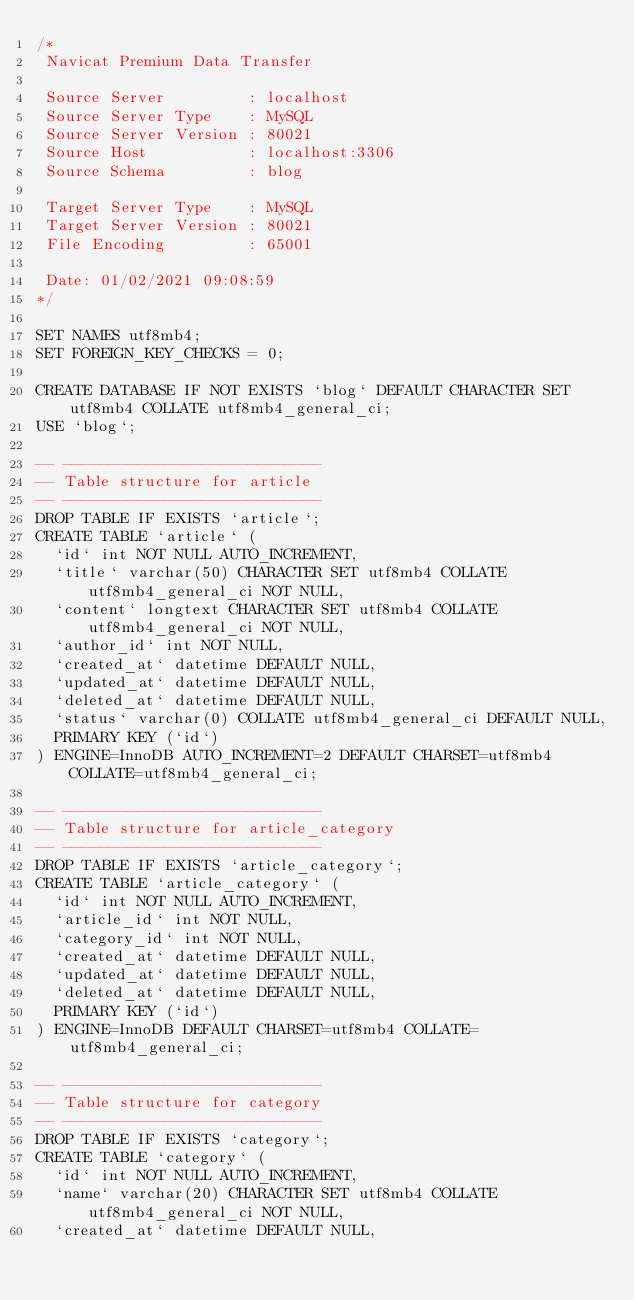Convert code to text. <code><loc_0><loc_0><loc_500><loc_500><_SQL_>/*
 Navicat Premium Data Transfer

 Source Server         : localhost
 Source Server Type    : MySQL
 Source Server Version : 80021
 Source Host           : localhost:3306
 Source Schema         : blog

 Target Server Type    : MySQL
 Target Server Version : 80021
 File Encoding         : 65001

 Date: 01/02/2021 09:08:59
*/

SET NAMES utf8mb4;
SET FOREIGN_KEY_CHECKS = 0;

CREATE DATABASE IF NOT EXISTS `blog` DEFAULT CHARACTER SET utf8mb4 COLLATE utf8mb4_general_ci;
USE `blog`;

-- ----------------------------
-- Table structure for article
-- ----------------------------
DROP TABLE IF EXISTS `article`;
CREATE TABLE `article` (
  `id` int NOT NULL AUTO_INCREMENT,
  `title` varchar(50) CHARACTER SET utf8mb4 COLLATE utf8mb4_general_ci NOT NULL,
  `content` longtext CHARACTER SET utf8mb4 COLLATE utf8mb4_general_ci NOT NULL,
  `author_id` int NOT NULL,
  `created_at` datetime DEFAULT NULL,
  `updated_at` datetime DEFAULT NULL,
  `deleted_at` datetime DEFAULT NULL,
  `status` varchar(0) COLLATE utf8mb4_general_ci DEFAULT NULL,
  PRIMARY KEY (`id`)
) ENGINE=InnoDB AUTO_INCREMENT=2 DEFAULT CHARSET=utf8mb4 COLLATE=utf8mb4_general_ci;

-- ----------------------------
-- Table structure for article_category
-- ----------------------------
DROP TABLE IF EXISTS `article_category`;
CREATE TABLE `article_category` (
  `id` int NOT NULL AUTO_INCREMENT,
  `article_id` int NOT NULL,
  `category_id` int NOT NULL,
  `created_at` datetime DEFAULT NULL,
  `updated_at` datetime DEFAULT NULL,
  `deleted_at` datetime DEFAULT NULL,
  PRIMARY KEY (`id`)
) ENGINE=InnoDB DEFAULT CHARSET=utf8mb4 COLLATE=utf8mb4_general_ci;

-- ----------------------------
-- Table structure for category
-- ----------------------------
DROP TABLE IF EXISTS `category`;
CREATE TABLE `category` (
  `id` int NOT NULL AUTO_INCREMENT,
  `name` varchar(20) CHARACTER SET utf8mb4 COLLATE utf8mb4_general_ci NOT NULL,
  `created_at` datetime DEFAULT NULL,</code> 